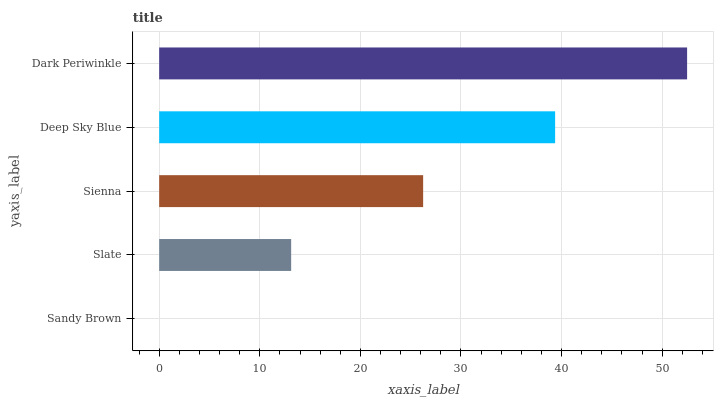Is Sandy Brown the minimum?
Answer yes or no. Yes. Is Dark Periwinkle the maximum?
Answer yes or no. Yes. Is Slate the minimum?
Answer yes or no. No. Is Slate the maximum?
Answer yes or no. No. Is Slate greater than Sandy Brown?
Answer yes or no. Yes. Is Sandy Brown less than Slate?
Answer yes or no. Yes. Is Sandy Brown greater than Slate?
Answer yes or no. No. Is Slate less than Sandy Brown?
Answer yes or no. No. Is Sienna the high median?
Answer yes or no. Yes. Is Sienna the low median?
Answer yes or no. Yes. Is Dark Periwinkle the high median?
Answer yes or no. No. Is Dark Periwinkle the low median?
Answer yes or no. No. 